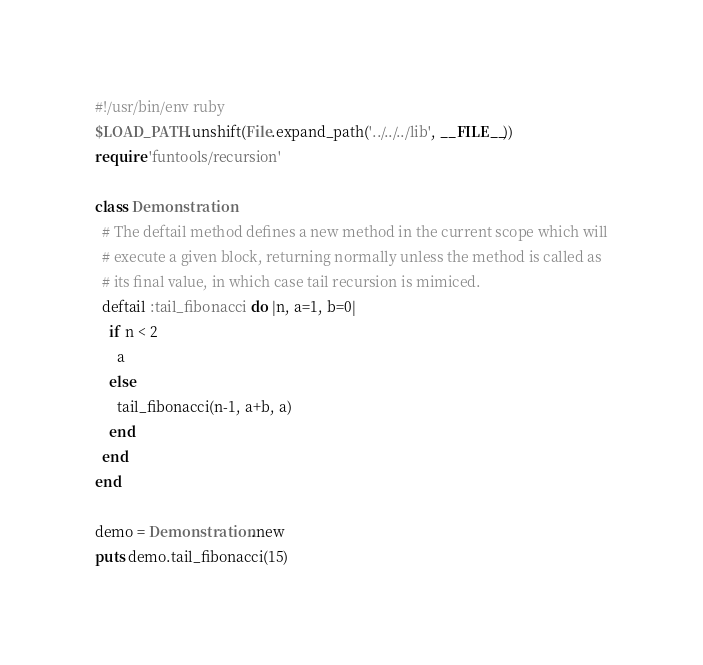<code> <loc_0><loc_0><loc_500><loc_500><_Ruby_>#!/usr/bin/env ruby
$LOAD_PATH.unshift(File.expand_path('../../../lib', __FILE__))
require 'funtools/recursion'

class Demonstration
  # The deftail method defines a new method in the current scope which will
  # execute a given block, returning normally unless the method is called as
  # its final value, in which case tail recursion is mimiced.
  deftail :tail_fibonacci do |n, a=1, b=0|
    if n < 2
      a
    else
      tail_fibonacci(n-1, a+b, a)
    end
  end
end

demo = Demonstration.new
puts demo.tail_fibonacci(15)
</code> 